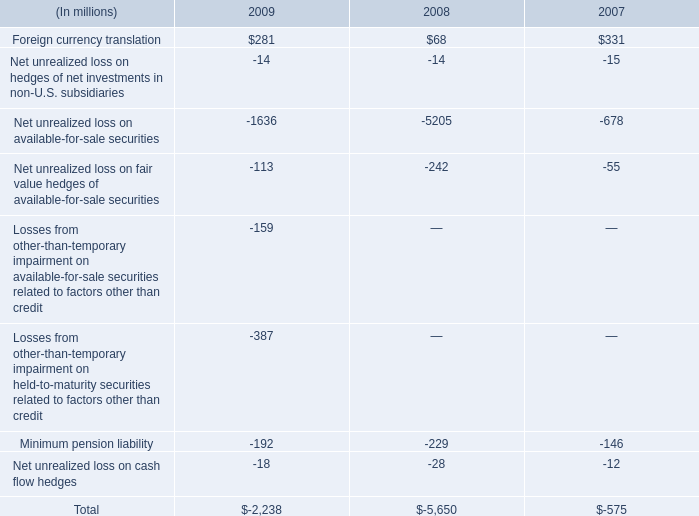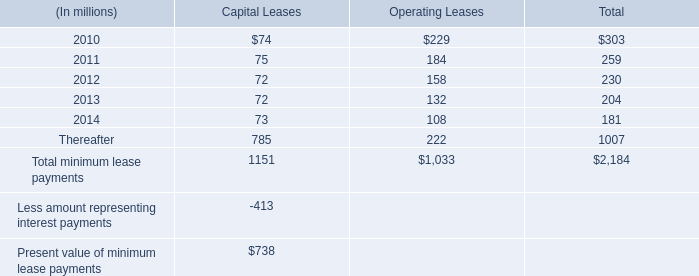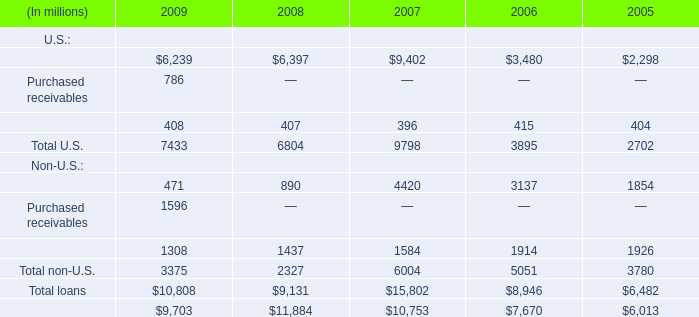What is the sum of U.S. in 2009 ? (in million) 
Computations: ((6239 + 786) + 408)
Answer: 7433.0. 